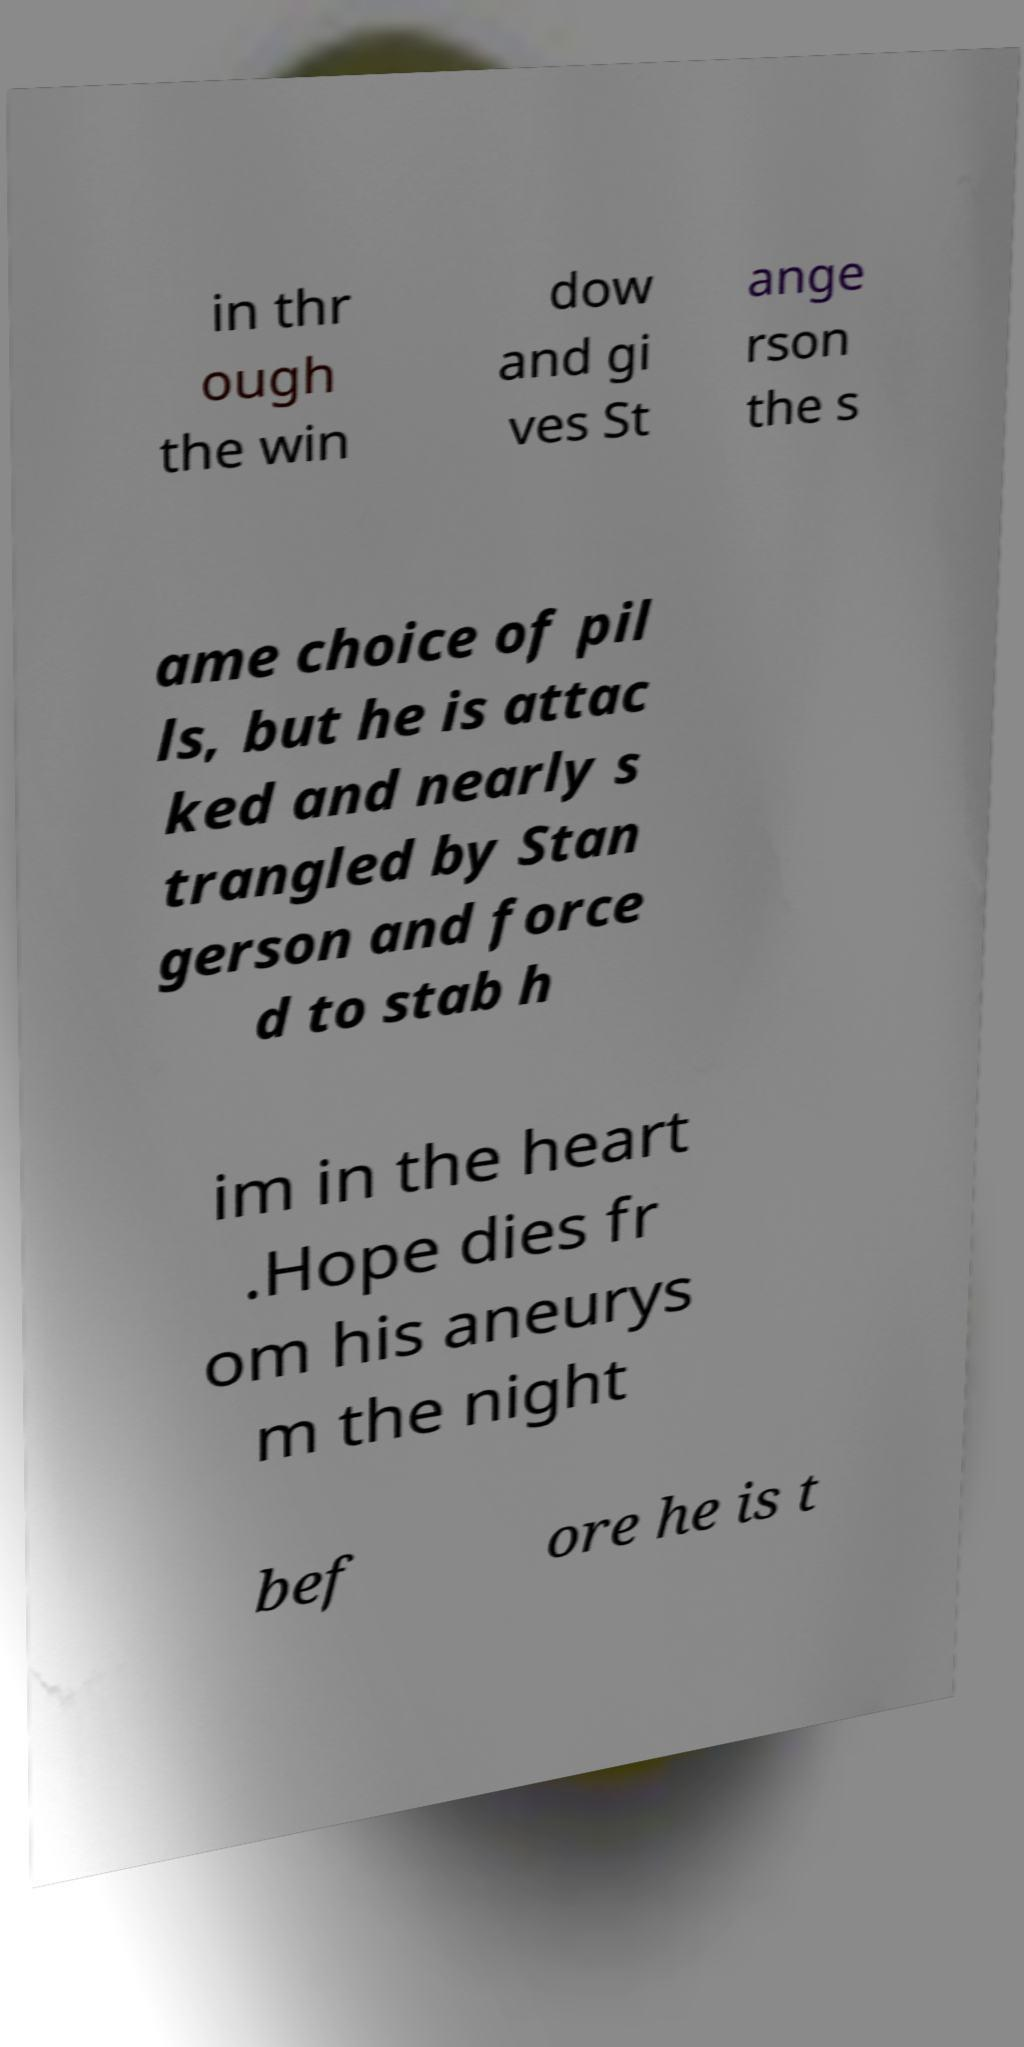Can you read and provide the text displayed in the image?This photo seems to have some interesting text. Can you extract and type it out for me? in thr ough the win dow and gi ves St ange rson the s ame choice of pil ls, but he is attac ked and nearly s trangled by Stan gerson and force d to stab h im in the heart .Hope dies fr om his aneurys m the night bef ore he is t 